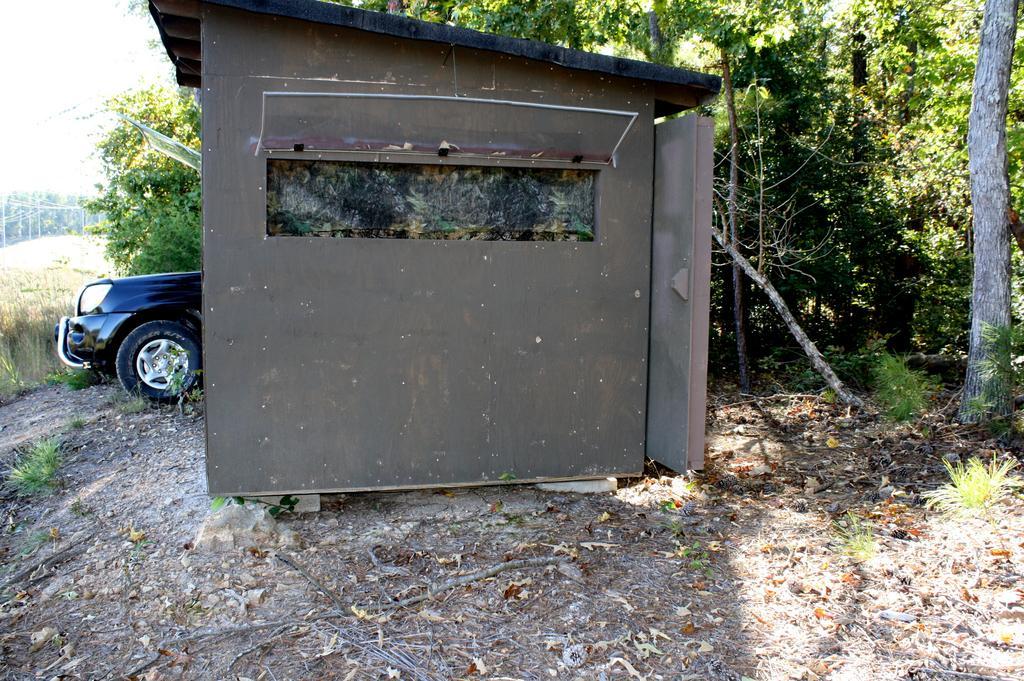Could you give a brief overview of what you see in this image? In the picture we can see a wooden house on the surface and besides to it we can see a car which is blue in color and to the path we can see some grass plants, trees. 